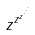Convert formula to latex. <formula><loc_0><loc_0><loc_500><loc_500>z ^ { z ^ { z ^ { \cdot ^ { \cdot ^ { \cdot } } } } }</formula> 